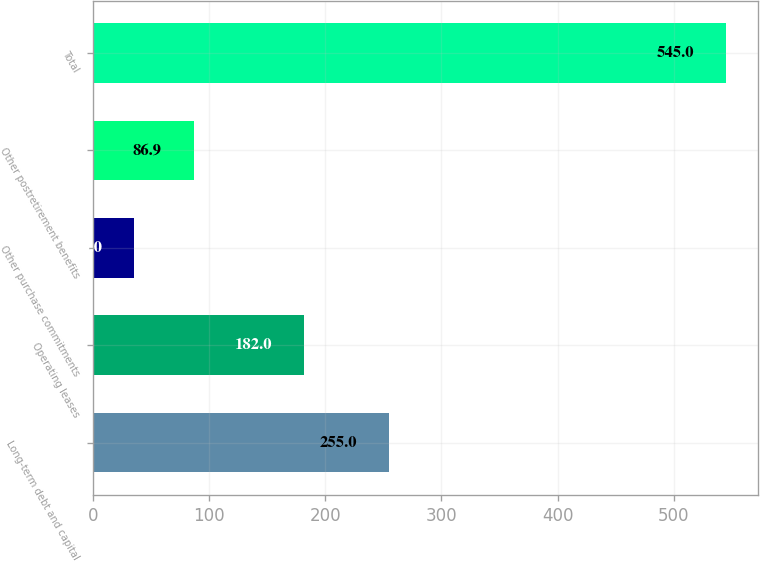Convert chart. <chart><loc_0><loc_0><loc_500><loc_500><bar_chart><fcel>Long-term debt and capital<fcel>Operating leases<fcel>Other purchase commitments<fcel>Other postretirement benefits<fcel>Total<nl><fcel>255<fcel>182<fcel>36<fcel>86.9<fcel>545<nl></chart> 